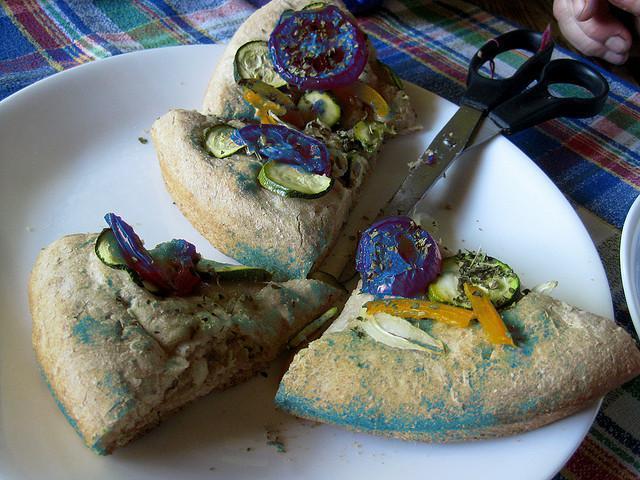How many scissors are there?
Give a very brief answer. 1. How many pizzas can you see?
Give a very brief answer. 4. 